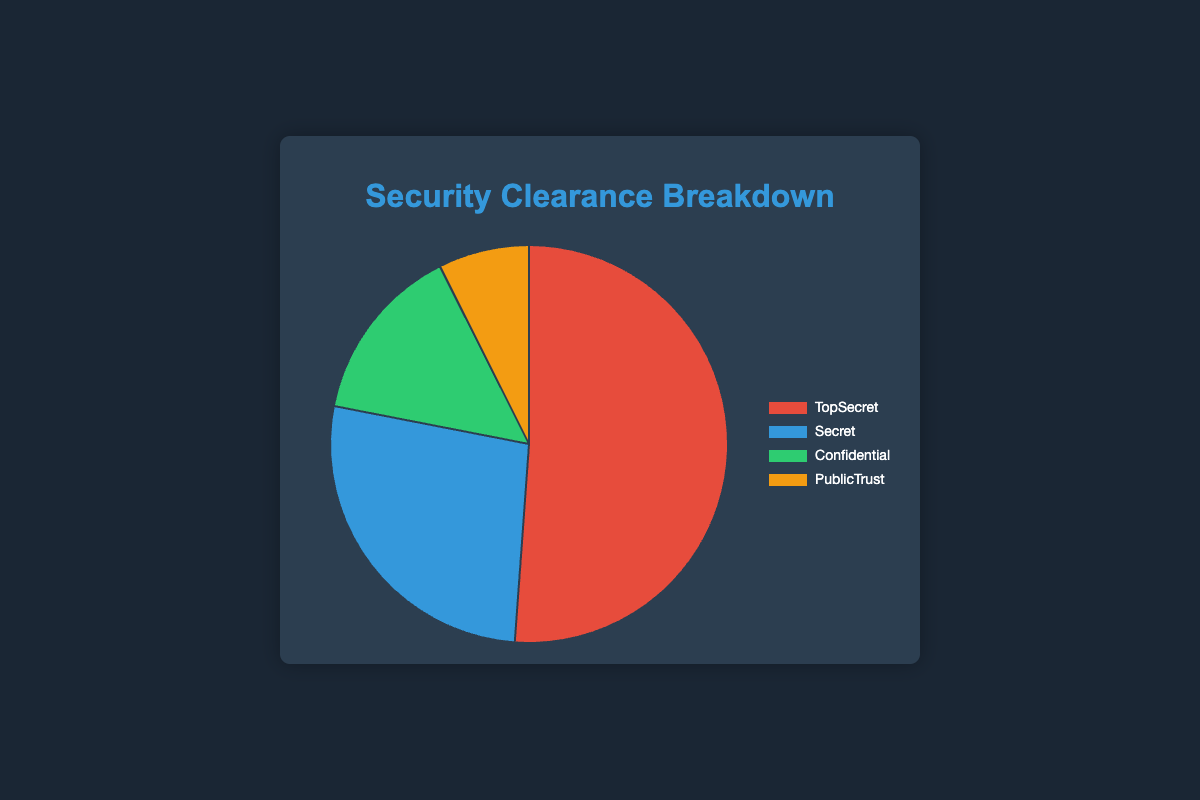Which security clearance level has the highest number of employees? By observing the pie chart, we can see which segment is the largest, indicating the highest number of employees.
Answer: Top Secret What percentage of employees hold a Secret clearance? To find the percentage of employees holding a Secret clearance, divide the number of employees with Secret clearance by the total number of employees, and then multiply by 100. 
Secret: (200 + 250 + 100 + 300 + 150) = 1000
Total employees: 500+450+300+400+250+200+250+100+300+150+100+120+80+150+90+50+60+40+70+55 = 4715
Percentage: (1000 / 4715) * 100 ≈ 21.2%
Answer: 21.2% Which agency has the highest number of Top Secret clearances? By referring to the data and the pie chart, identify the agency with the most significant number in the Top Secret section: 
CIA: 500
NSA: 450
DIA: 300
FBI: 400
NRO: 250 The agency with the maximum value is the CIA.
Answer: CIA Compare the total number of employees with Confidential clearances to those with Public Trust clearances. Calculate the sum of all employees with Confidential and Public Trust clearances and then compare the two sums. 
Confidential: (100 + 120 + 80 + 150 + 90) = 540
Public Trust: (50 + 60 + 40 + 70 + 55) = 275 
Since 540 is greater than 275, Confidential clearances are higher.
Answer: Confidential What is the combined total number of employees with either Top Secret or Secret clearances in the DIA? Add the number of employees with Top Secret and Secret clearances in the DIA:
Top Secret DIA: 300
Secret DIA: 100
Combined total: 300 + 100 = 400
Answer: 400 Which clearance level corresponds to the yellow segment in the pie chart? The yellow segment in the pie chart represents the one with a specific number of employees. Using the segment colors and data:
Top Secret: Red
Secret: Blue
Confidential: Green
Public Trust: Yellow
Thus, Public Trust corresponds to the yellow segment.
Answer: Public Trust Calculate the average number of employees with any level of clearance across all agencies. Calculate the sum of all employees and divide by the number of agencies and levels for an average:
Total employees: 4715 (sum of all)
Number of agencies: 5 
Number of clearance levels: 4
Average per agency level = 4715 / (5 * 4) = 4715 / 20 = 235.75
Answer: 235.75 